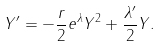<formula> <loc_0><loc_0><loc_500><loc_500>Y ^ { \prime } = - \frac { r } { 2 } e ^ { \lambda } Y ^ { 2 } + \frac { \lambda ^ { \prime } } 2 Y .</formula> 